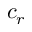Convert formula to latex. <formula><loc_0><loc_0><loc_500><loc_500>c _ { r }</formula> 